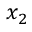Convert formula to latex. <formula><loc_0><loc_0><loc_500><loc_500>x _ { 2 }</formula> 